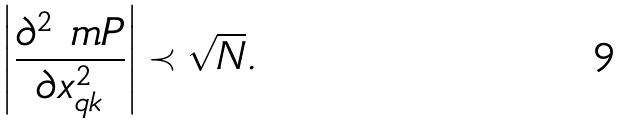<formula> <loc_0><loc_0><loc_500><loc_500>\left | \frac { \partial ^ { 2 } \ m P } { \partial x _ { q k } ^ { 2 } } \right | \prec \sqrt { N } .</formula> 